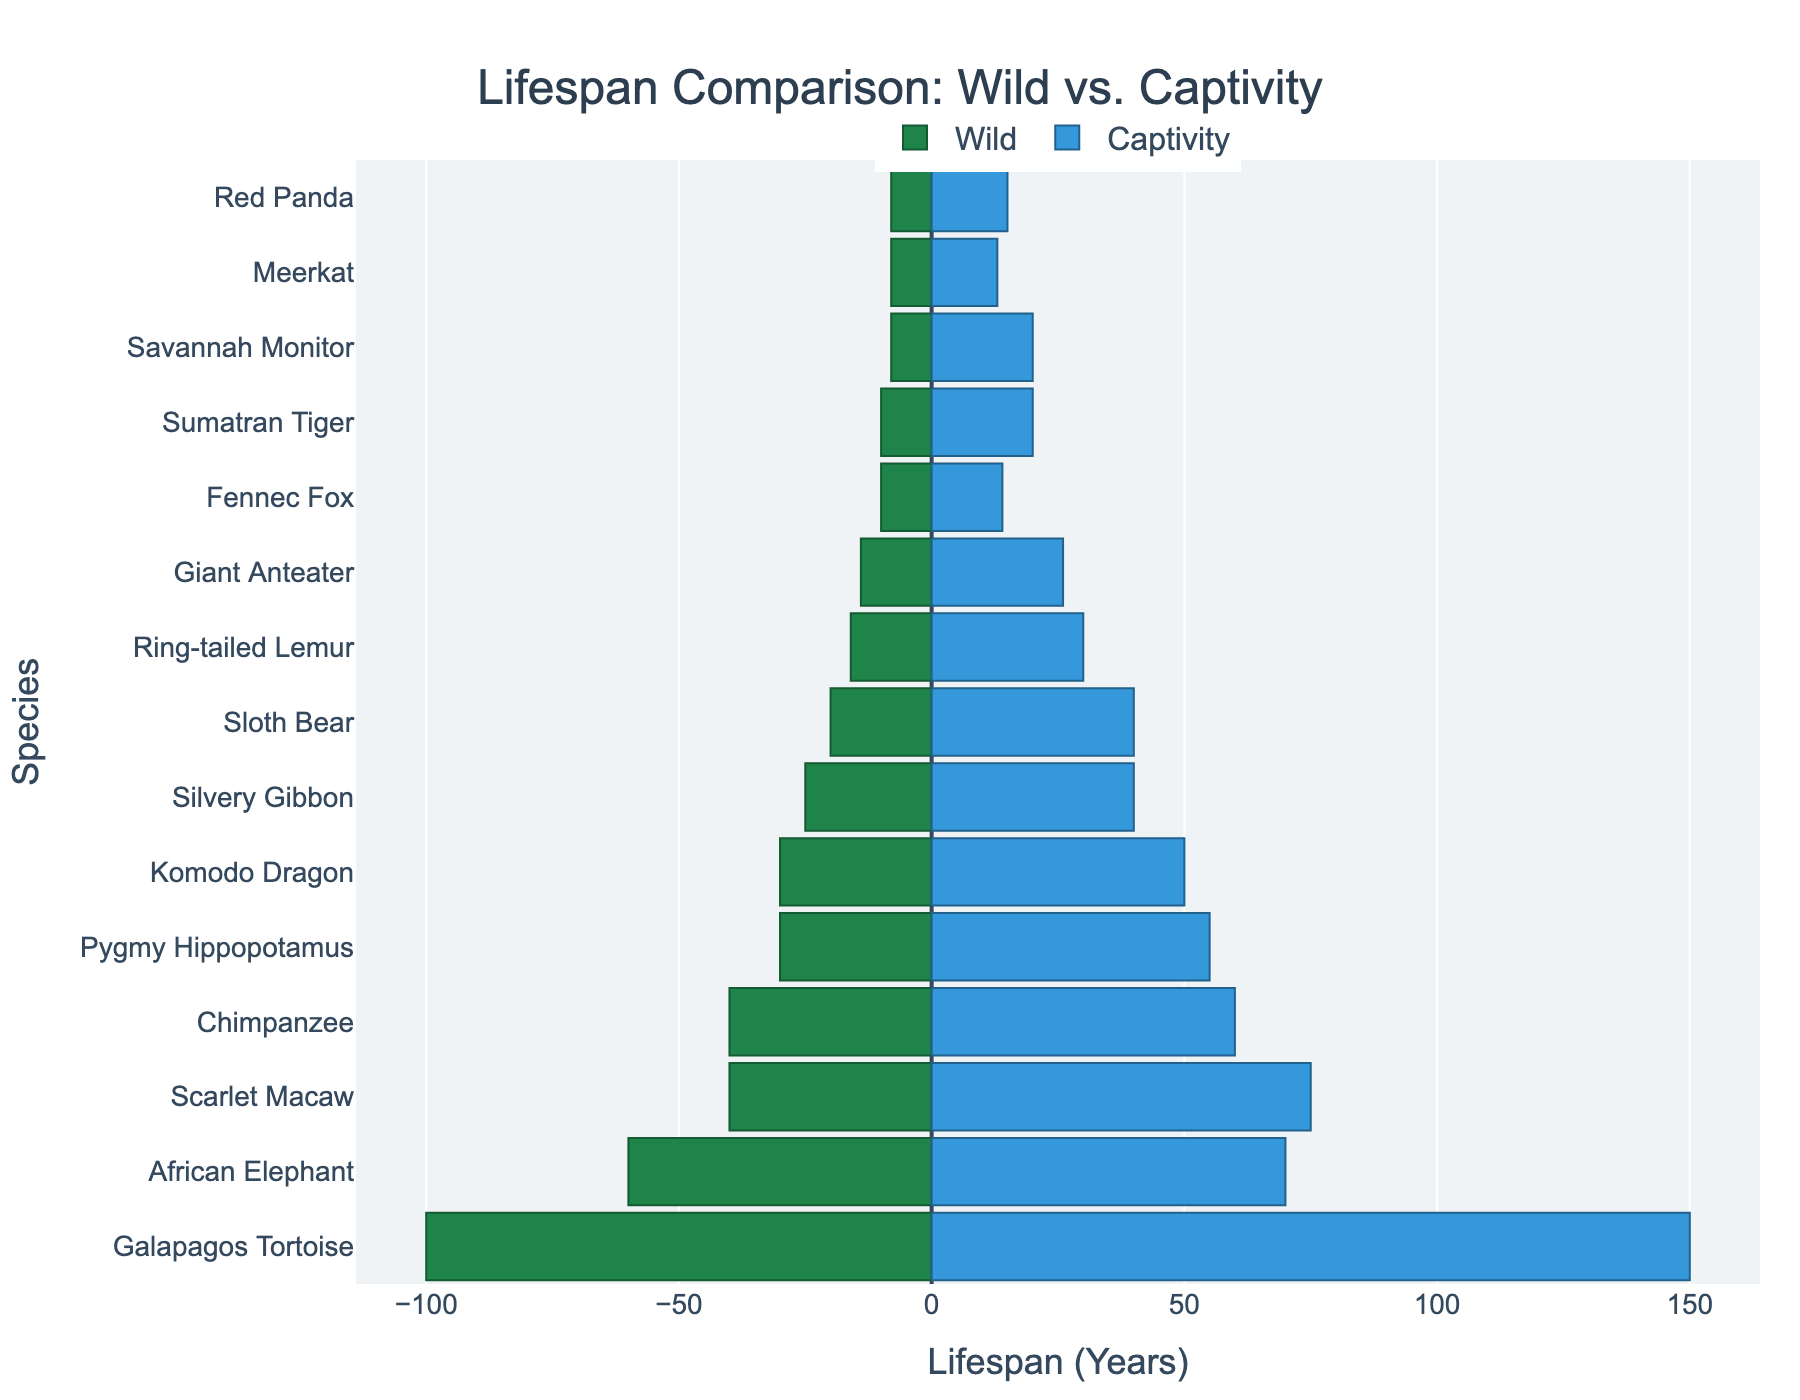What is the title of the figure? The title is prominently displayed at the top of the figure. It helps summarize what the data visualizes.
Answer: Lifespan Comparison: Wild vs. Captivity Which species has the longest lifespan in captivity? By looking at the right-side bars (representing captivity lifespan), we can find the longest bar. The Galapagos Tortoise shows the longest bar, reaching 150 years.
Answer: Galapagos Tortoise Which species shows the greatest increase in lifespan from the wild to captivity? To find this, we need to look at the difference in bar lengths for each species. The Scarlet Macaw shows a significant increase, from 40 years in the wild to 75 years in captivity. This is an increase of 35 years.
Answer: Scarlet Macaw How many species have a longer lifespan in captivity compared to the wild? All the species listed in the figure have longer bars on the right side (captivity) compared to the left side (wild). Counting these species gives us 15.
Answer: 15 What is the average lifespan of a Sumatran Tiger in captivity? The bar for the captivity lifespan of the Sumatran Tiger reaches 20 years.
Answer: 20 years Which species has the smallest difference in lifespan between wild and captivity? By comparing the lengths of the bars for wild and captivity across species, the Fennec Fox shows the smallest difference. It lives 10 years in the wild and 14 years in captivity, a difference of 4 years.
Answer: Fennec Fox For which species is the captivity lifespan more than twice the wild lifespan? We need to look for species where the captivity lifespan bar is more than double the wild lifespan bar. The Sumatran Tiger (20 vs. 10) and Ring-tailed Lemur (30 vs. 16) both meet this criterion.
Answer: Sumatran Tiger, Ring-tailed Lemur What is the combined lifespan in captivity for the African Elephant and Chimpanzee? Adding the lifespan of the African Elephant (70 years) and the Chimpanzee (60 years) in captivity gives us 70 + 60 = 130 years.
Answer: 130 years What species has a captive lifespan exactly 10 years longer than its wild lifespan? Comparing the difference between the bars for each species, the African Elephant has a captive lifespan of 70 years which is 10 years longer than its wild lifespan of 60 years.
Answer: African Elephant 